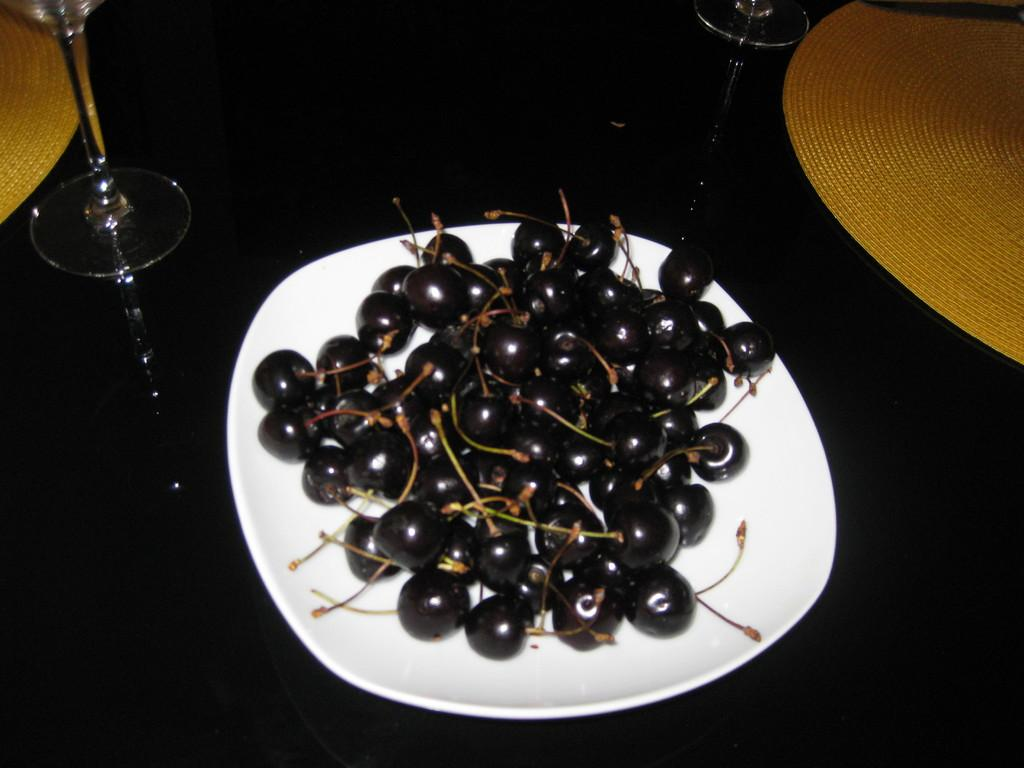What is the main object in the center of the image? There is a plate in the center of the image. What is on the plate? The plate contains superfood. What else can be seen in the image besides the plate? There are glasses at the top side of the image. What type of scent can be detected from the superfood on the plate? There is no information about the scent of the superfood in the image, so it cannot be determined. 